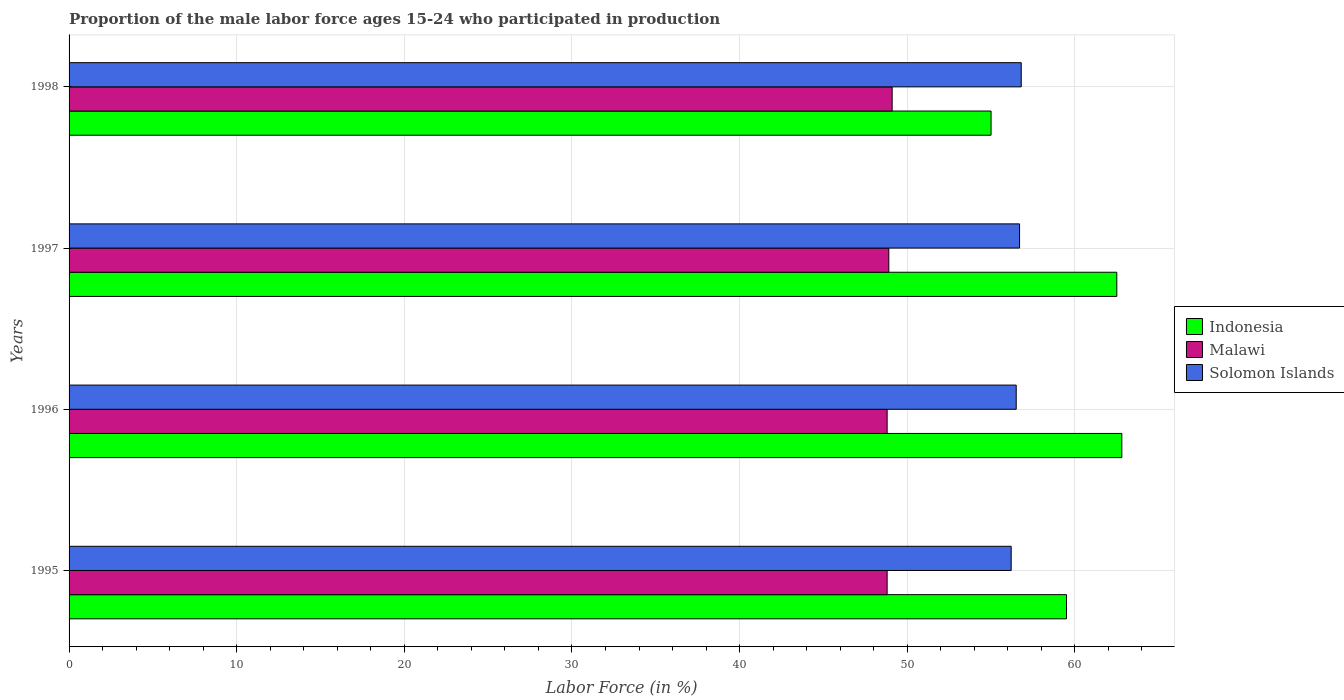How many different coloured bars are there?
Provide a succinct answer. 3. How many groups of bars are there?
Give a very brief answer. 4. Are the number of bars per tick equal to the number of legend labels?
Your answer should be very brief. Yes. How many bars are there on the 3rd tick from the top?
Provide a succinct answer. 3. How many bars are there on the 1st tick from the bottom?
Offer a very short reply. 3. What is the label of the 4th group of bars from the top?
Keep it short and to the point. 1995. In how many cases, is the number of bars for a given year not equal to the number of legend labels?
Provide a succinct answer. 0. What is the proportion of the male labor force who participated in production in Indonesia in 1997?
Provide a short and direct response. 62.5. Across all years, what is the maximum proportion of the male labor force who participated in production in Solomon Islands?
Ensure brevity in your answer.  56.8. Across all years, what is the minimum proportion of the male labor force who participated in production in Solomon Islands?
Your answer should be very brief. 56.2. In which year was the proportion of the male labor force who participated in production in Solomon Islands maximum?
Keep it short and to the point. 1998. In which year was the proportion of the male labor force who participated in production in Indonesia minimum?
Your answer should be compact. 1998. What is the total proportion of the male labor force who participated in production in Indonesia in the graph?
Give a very brief answer. 239.8. What is the difference between the proportion of the male labor force who participated in production in Malawi in 1996 and that in 1998?
Make the answer very short. -0.3. What is the difference between the proportion of the male labor force who participated in production in Malawi in 1998 and the proportion of the male labor force who participated in production in Indonesia in 1995?
Your answer should be very brief. -10.4. What is the average proportion of the male labor force who participated in production in Solomon Islands per year?
Keep it short and to the point. 56.55. In the year 1995, what is the difference between the proportion of the male labor force who participated in production in Malawi and proportion of the male labor force who participated in production in Indonesia?
Offer a terse response. -10.7. What is the ratio of the proportion of the male labor force who participated in production in Malawi in 1996 to that in 1998?
Your answer should be compact. 0.99. Is the difference between the proportion of the male labor force who participated in production in Malawi in 1995 and 1998 greater than the difference between the proportion of the male labor force who participated in production in Indonesia in 1995 and 1998?
Your answer should be very brief. No. What is the difference between the highest and the second highest proportion of the male labor force who participated in production in Solomon Islands?
Offer a terse response. 0.1. What is the difference between the highest and the lowest proportion of the male labor force who participated in production in Solomon Islands?
Keep it short and to the point. 0.6. In how many years, is the proportion of the male labor force who participated in production in Solomon Islands greater than the average proportion of the male labor force who participated in production in Solomon Islands taken over all years?
Keep it short and to the point. 2. What does the 1st bar from the top in 1998 represents?
Your answer should be very brief. Solomon Islands. What does the 2nd bar from the bottom in 1998 represents?
Keep it short and to the point. Malawi. Is it the case that in every year, the sum of the proportion of the male labor force who participated in production in Indonesia and proportion of the male labor force who participated in production in Solomon Islands is greater than the proportion of the male labor force who participated in production in Malawi?
Your answer should be very brief. Yes. How many bars are there?
Provide a short and direct response. 12. Are all the bars in the graph horizontal?
Make the answer very short. Yes. Are the values on the major ticks of X-axis written in scientific E-notation?
Provide a short and direct response. No. Does the graph contain any zero values?
Offer a very short reply. No. Where does the legend appear in the graph?
Keep it short and to the point. Center right. What is the title of the graph?
Give a very brief answer. Proportion of the male labor force ages 15-24 who participated in production. Does "Middle East & North Africa (developing only)" appear as one of the legend labels in the graph?
Give a very brief answer. No. What is the label or title of the Y-axis?
Provide a succinct answer. Years. What is the Labor Force (in %) in Indonesia in 1995?
Your answer should be very brief. 59.5. What is the Labor Force (in %) of Malawi in 1995?
Your answer should be compact. 48.8. What is the Labor Force (in %) of Solomon Islands in 1995?
Offer a terse response. 56.2. What is the Labor Force (in %) of Indonesia in 1996?
Your answer should be compact. 62.8. What is the Labor Force (in %) in Malawi in 1996?
Make the answer very short. 48.8. What is the Labor Force (in %) of Solomon Islands in 1996?
Your answer should be very brief. 56.5. What is the Labor Force (in %) of Indonesia in 1997?
Offer a terse response. 62.5. What is the Labor Force (in %) in Malawi in 1997?
Ensure brevity in your answer.  48.9. What is the Labor Force (in %) in Solomon Islands in 1997?
Offer a very short reply. 56.7. What is the Labor Force (in %) in Malawi in 1998?
Your response must be concise. 49.1. What is the Labor Force (in %) of Solomon Islands in 1998?
Ensure brevity in your answer.  56.8. Across all years, what is the maximum Labor Force (in %) of Indonesia?
Your response must be concise. 62.8. Across all years, what is the maximum Labor Force (in %) of Malawi?
Ensure brevity in your answer.  49.1. Across all years, what is the maximum Labor Force (in %) in Solomon Islands?
Give a very brief answer. 56.8. Across all years, what is the minimum Labor Force (in %) of Malawi?
Offer a terse response. 48.8. Across all years, what is the minimum Labor Force (in %) in Solomon Islands?
Give a very brief answer. 56.2. What is the total Labor Force (in %) of Indonesia in the graph?
Provide a short and direct response. 239.8. What is the total Labor Force (in %) in Malawi in the graph?
Make the answer very short. 195.6. What is the total Labor Force (in %) of Solomon Islands in the graph?
Your answer should be compact. 226.2. What is the difference between the Labor Force (in %) of Malawi in 1995 and that in 1996?
Provide a short and direct response. 0. What is the difference between the Labor Force (in %) of Malawi in 1995 and that in 1997?
Offer a very short reply. -0.1. What is the difference between the Labor Force (in %) of Indonesia in 1995 and that in 1998?
Give a very brief answer. 4.5. What is the difference between the Labor Force (in %) in Malawi in 1995 and that in 1998?
Offer a very short reply. -0.3. What is the difference between the Labor Force (in %) in Indonesia in 1996 and that in 1997?
Your answer should be very brief. 0.3. What is the difference between the Labor Force (in %) in Malawi in 1996 and that in 1997?
Ensure brevity in your answer.  -0.1. What is the difference between the Labor Force (in %) in Solomon Islands in 1996 and that in 1997?
Make the answer very short. -0.2. What is the difference between the Labor Force (in %) in Indonesia in 1996 and that in 1998?
Your answer should be compact. 7.8. What is the difference between the Labor Force (in %) in Solomon Islands in 1997 and that in 1998?
Keep it short and to the point. -0.1. What is the difference between the Labor Force (in %) in Indonesia in 1995 and the Labor Force (in %) in Solomon Islands in 1996?
Offer a terse response. 3. What is the difference between the Labor Force (in %) in Malawi in 1995 and the Labor Force (in %) in Solomon Islands in 1996?
Provide a short and direct response. -7.7. What is the difference between the Labor Force (in %) in Indonesia in 1995 and the Labor Force (in %) in Solomon Islands in 1997?
Offer a terse response. 2.8. What is the difference between the Labor Force (in %) of Indonesia in 1995 and the Labor Force (in %) of Malawi in 1998?
Offer a terse response. 10.4. What is the difference between the Labor Force (in %) of Indonesia in 1995 and the Labor Force (in %) of Solomon Islands in 1998?
Your answer should be compact. 2.7. What is the difference between the Labor Force (in %) of Indonesia in 1996 and the Labor Force (in %) of Malawi in 1997?
Keep it short and to the point. 13.9. What is the difference between the Labor Force (in %) of Indonesia in 1996 and the Labor Force (in %) of Solomon Islands in 1997?
Make the answer very short. 6.1. What is the difference between the Labor Force (in %) in Indonesia in 1996 and the Labor Force (in %) in Malawi in 1998?
Offer a very short reply. 13.7. What is the difference between the Labor Force (in %) of Indonesia in 1996 and the Labor Force (in %) of Solomon Islands in 1998?
Give a very brief answer. 6. What is the average Labor Force (in %) in Indonesia per year?
Give a very brief answer. 59.95. What is the average Labor Force (in %) in Malawi per year?
Offer a very short reply. 48.9. What is the average Labor Force (in %) of Solomon Islands per year?
Your answer should be very brief. 56.55. In the year 1995, what is the difference between the Labor Force (in %) of Indonesia and Labor Force (in %) of Solomon Islands?
Provide a succinct answer. 3.3. In the year 1996, what is the difference between the Labor Force (in %) of Indonesia and Labor Force (in %) of Malawi?
Provide a short and direct response. 14. In the year 1996, what is the difference between the Labor Force (in %) of Indonesia and Labor Force (in %) of Solomon Islands?
Give a very brief answer. 6.3. In the year 1996, what is the difference between the Labor Force (in %) in Malawi and Labor Force (in %) in Solomon Islands?
Offer a very short reply. -7.7. In the year 1997, what is the difference between the Labor Force (in %) in Indonesia and Labor Force (in %) in Malawi?
Make the answer very short. 13.6. In the year 1997, what is the difference between the Labor Force (in %) in Indonesia and Labor Force (in %) in Solomon Islands?
Keep it short and to the point. 5.8. In the year 1998, what is the difference between the Labor Force (in %) in Indonesia and Labor Force (in %) in Malawi?
Offer a very short reply. 5.9. What is the ratio of the Labor Force (in %) of Indonesia in 1995 to that in 1996?
Offer a very short reply. 0.95. What is the ratio of the Labor Force (in %) of Malawi in 1995 to that in 1996?
Give a very brief answer. 1. What is the ratio of the Labor Force (in %) in Solomon Islands in 1995 to that in 1996?
Provide a succinct answer. 0.99. What is the ratio of the Labor Force (in %) of Indonesia in 1995 to that in 1998?
Offer a very short reply. 1.08. What is the ratio of the Labor Force (in %) of Malawi in 1995 to that in 1998?
Offer a very short reply. 0.99. What is the ratio of the Labor Force (in %) of Indonesia in 1996 to that in 1997?
Keep it short and to the point. 1. What is the ratio of the Labor Force (in %) in Solomon Islands in 1996 to that in 1997?
Your answer should be very brief. 1. What is the ratio of the Labor Force (in %) of Indonesia in 1996 to that in 1998?
Ensure brevity in your answer.  1.14. What is the ratio of the Labor Force (in %) of Solomon Islands in 1996 to that in 1998?
Provide a succinct answer. 0.99. What is the ratio of the Labor Force (in %) in Indonesia in 1997 to that in 1998?
Your answer should be very brief. 1.14. What is the ratio of the Labor Force (in %) of Solomon Islands in 1997 to that in 1998?
Your answer should be very brief. 1. What is the difference between the highest and the second highest Labor Force (in %) in Malawi?
Your answer should be compact. 0.2. What is the difference between the highest and the second highest Labor Force (in %) in Solomon Islands?
Provide a short and direct response. 0.1. What is the difference between the highest and the lowest Labor Force (in %) in Malawi?
Your response must be concise. 0.3. 